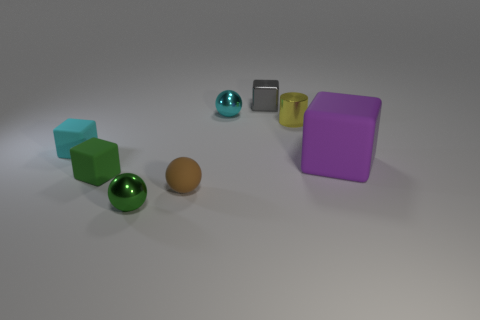Are there any other small cylinders of the same color as the tiny cylinder?
Your answer should be very brief. No. Does the rubber object behind the purple cube have the same size as the rubber ball?
Ensure brevity in your answer.  Yes. The metal block has what color?
Your response must be concise. Gray. What is the color of the tiny sphere that is right of the tiny matte object that is to the right of the small green matte object?
Your answer should be very brief. Cyan. Is there a tiny green cube made of the same material as the green sphere?
Your answer should be compact. No. What is the small cube behind the ball right of the tiny brown sphere made of?
Provide a succinct answer. Metal. What number of yellow metallic things are the same shape as the gray thing?
Give a very brief answer. 0. What is the shape of the large object?
Your response must be concise. Cube. Are there fewer small gray things than large blue metal cylinders?
Your response must be concise. No. Is there any other thing that has the same size as the cyan metallic sphere?
Offer a terse response. Yes. 